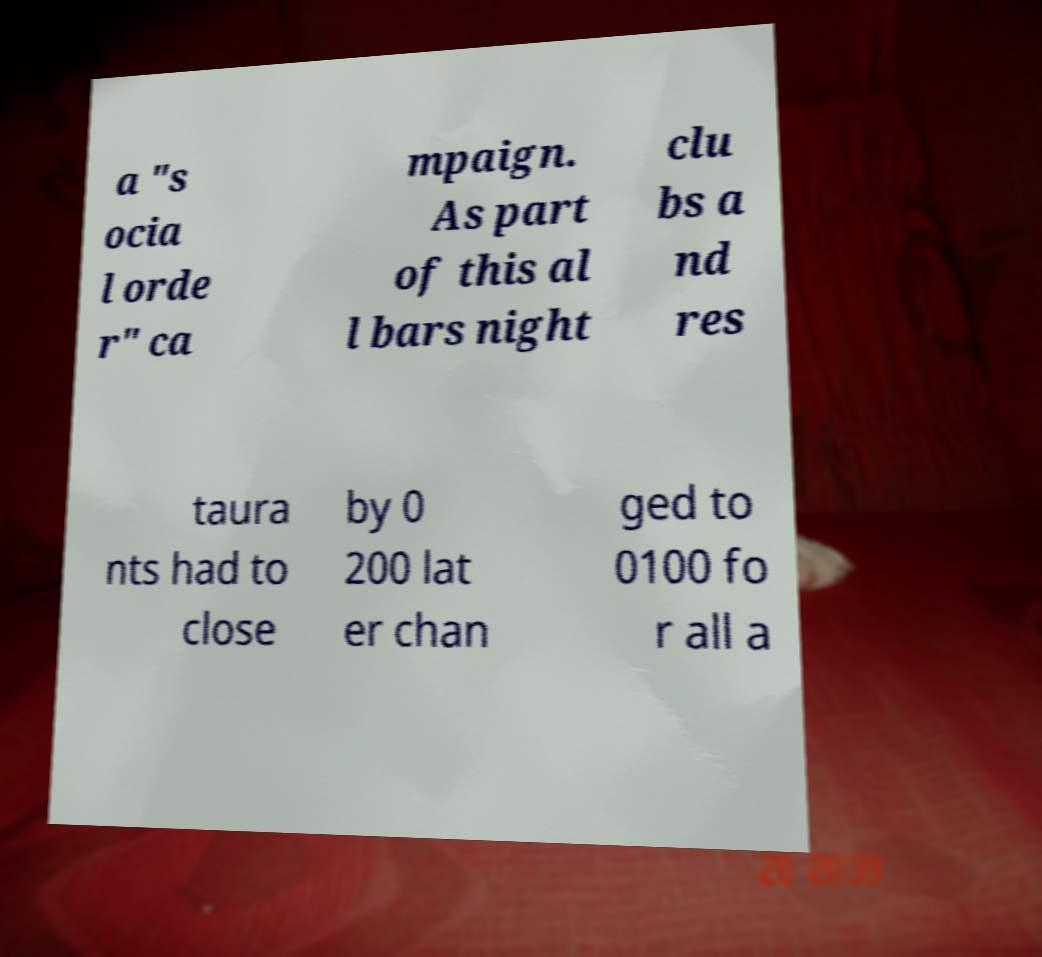For documentation purposes, I need the text within this image transcribed. Could you provide that? a "s ocia l orde r" ca mpaign. As part of this al l bars night clu bs a nd res taura nts had to close by 0 200 lat er chan ged to 0100 fo r all a 